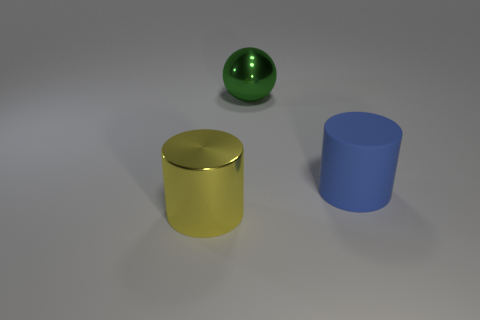Is there anything else that is made of the same material as the large blue object?
Make the answer very short. No. There is a big shiny thing that is to the left of the large green metallic object that is behind the big yellow metallic cylinder; what number of yellow metal objects are in front of it?
Your answer should be compact. 0. What number of cubes are large yellow metal things or blue matte objects?
Provide a short and direct response. 0. What is the color of the cylinder behind the large cylinder that is left of the big metallic object on the right side of the metallic cylinder?
Provide a succinct answer. Blue. What number of other objects are the same size as the green sphere?
Your answer should be compact. 2. Is there any other thing that has the same shape as the large green thing?
Ensure brevity in your answer.  No. What color is the other thing that is the same shape as the large yellow thing?
Provide a succinct answer. Blue. There is a cylinder that is the same material as the big sphere; what color is it?
Ensure brevity in your answer.  Yellow. Are there the same number of big yellow shiny things that are to the left of the large yellow object and large yellow objects?
Offer a very short reply. No. Does the cylinder that is on the left side of the rubber cylinder have the same size as the blue matte thing?
Offer a terse response. Yes. 